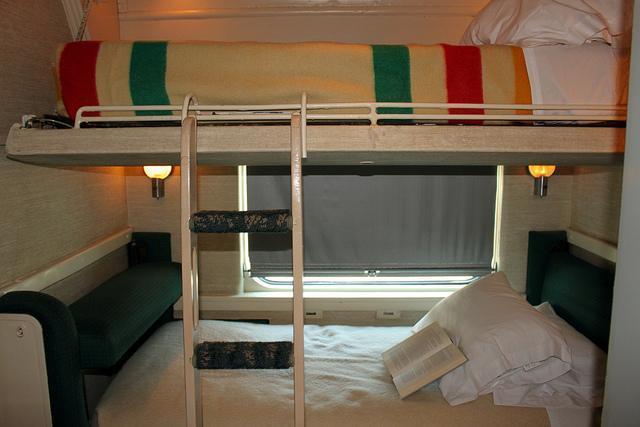Where might these sleeping quarters be located?
Answer the question by selecting the correct answer among the 4 following choices.
Options: Home, train, bus, car. Train. 